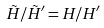Convert formula to latex. <formula><loc_0><loc_0><loc_500><loc_500>\tilde { H } / \tilde { H } ^ { \prime } = H / H ^ { \prime }</formula> 